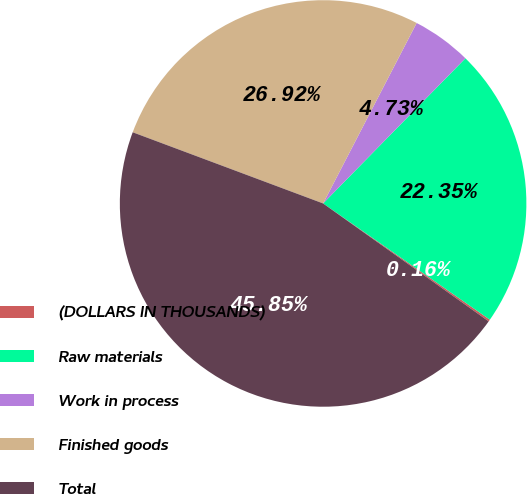<chart> <loc_0><loc_0><loc_500><loc_500><pie_chart><fcel>(DOLLARS IN THOUSANDS)<fcel>Raw materials<fcel>Work in process<fcel>Finished goods<fcel>Total<nl><fcel>0.16%<fcel>22.35%<fcel>4.73%<fcel>26.92%<fcel>45.85%<nl></chart> 